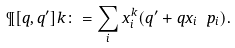<formula> <loc_0><loc_0><loc_500><loc_500>\P [ q , q ^ { \prime } ] k \colon = \sum _ { i } x _ { i } ^ { k } ( q ^ { \prime } + q x _ { i } \ p _ { i } ) .</formula> 